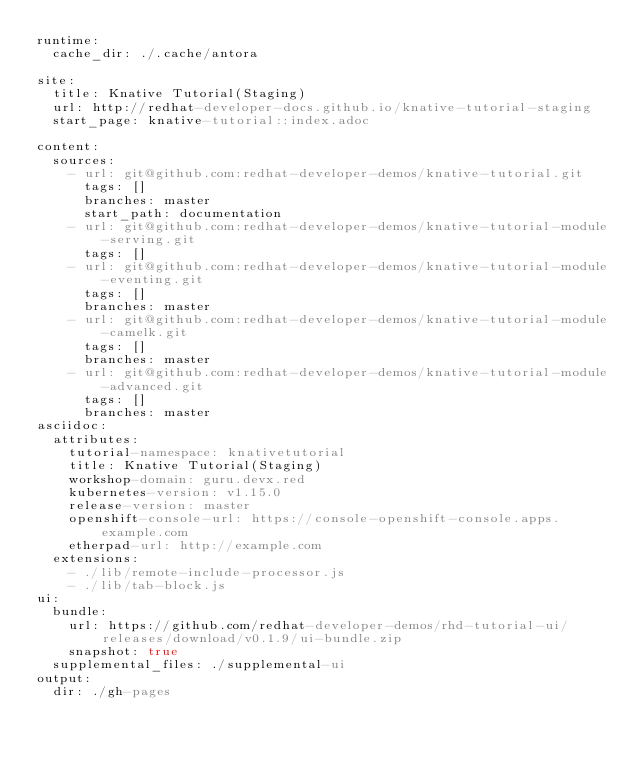Convert code to text. <code><loc_0><loc_0><loc_500><loc_500><_YAML_>runtime:
  cache_dir: ./.cache/antora

site:
  title: Knative Tutorial(Staging)
  url: http://redhat-developer-docs.github.io/knative-tutorial-staging
  start_page: knative-tutorial::index.adoc

content:
  sources:
    - url: git@github.com:redhat-developer-demos/knative-tutorial.git
      tags: []
      branches: master
      start_path: documentation
    - url: git@github.com:redhat-developer-demos/knative-tutorial-module-serving.git
      tags: []
    - url: git@github.com:redhat-developer-demos/knative-tutorial-module-eventing.git
      tags: []
      branches: master
    - url: git@github.com:redhat-developer-demos/knative-tutorial-module-camelk.git
      tags: []
      branches: master
    - url: git@github.com:redhat-developer-demos/knative-tutorial-module-advanced.git
      tags: []
      branches: master
asciidoc:
  attributes:
    tutorial-namespace: knativetutorial
    title: Knative Tutorial(Staging)
    workshop-domain: guru.devx.red
    kubernetes-version: v1.15.0
    release-version: master
    openshift-console-url: https://console-openshift-console.apps.example.com
    etherpad-url: http://example.com
  extensions:
    - ./lib/remote-include-processor.js
    - ./lib/tab-block.js
ui:
  bundle:
    url: https://github.com/redhat-developer-demos/rhd-tutorial-ui/releases/download/v0.1.9/ui-bundle.zip
    snapshot: true
  supplemental_files: ./supplemental-ui
output:
  dir: ./gh-pages
</code> 